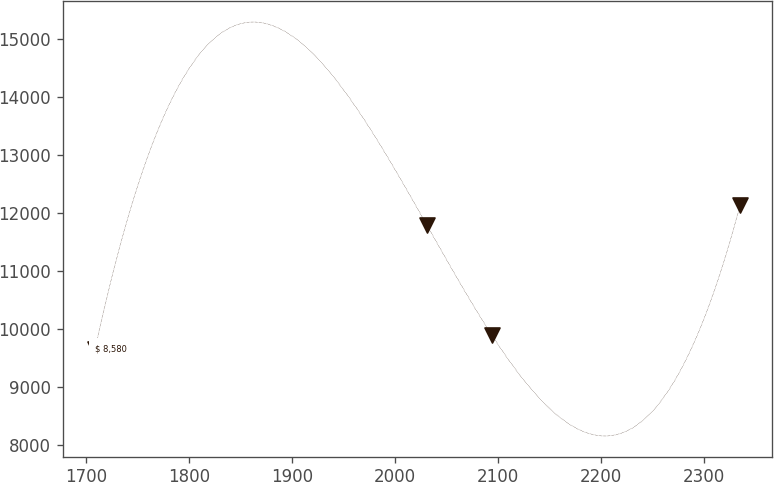Convert chart to OTSL. <chart><loc_0><loc_0><loc_500><loc_500><line_chart><ecel><fcel>$ 8,580<nl><fcel>1708.69<fcel>9655.72<nl><fcel>2030.96<fcel>11785.3<nl><fcel>2093.59<fcel>9904.35<nl><fcel>2334.99<fcel>12142<nl></chart> 